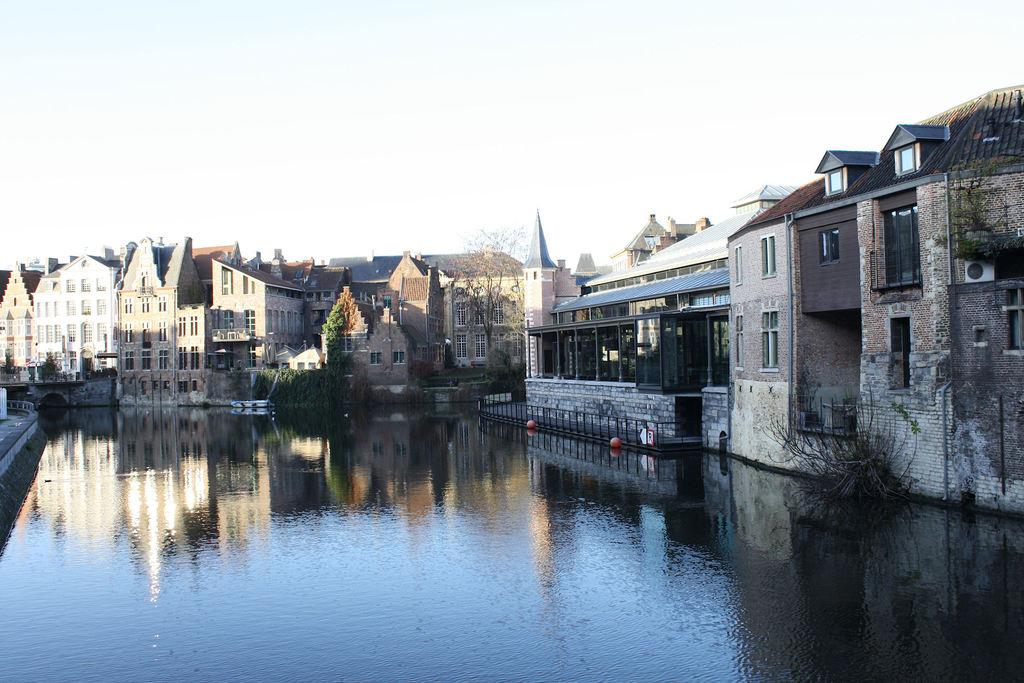What type of structures can be seen in the middle of the image? There are buildings visible in the middle of the image. What is located in front of the buildings? Trees are present in front of the buildings. What body of water can be seen in the image? There is a lake visible in the image. What is visible in the background of the image? The sky is visible in the background of the image. How many cakes are being served by the police officer near the lake? There is no police officer or cake present in the image. What type of cub can be seen playing with the trees in front of the buildings? There is no cub present in the image; only buildings, trees, and a lake are visible. 